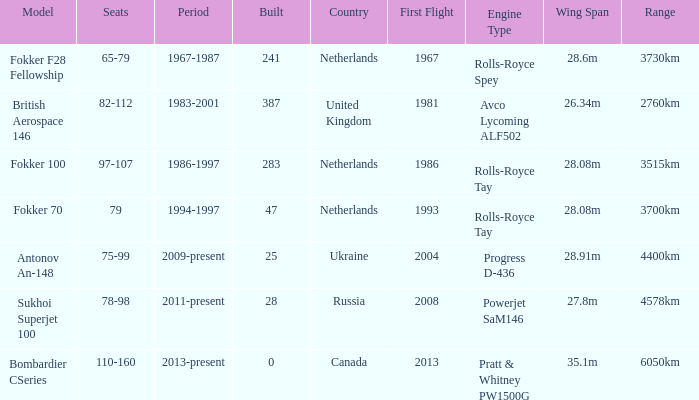Parse the table in full. {'header': ['Model', 'Seats', 'Period', 'Built', 'Country', 'First Flight', 'Engine Type', 'Wing Span', 'Range'], 'rows': [['Fokker F28 Fellowship', '65-79', '1967-1987', '241', 'Netherlands', '1967', 'Rolls-Royce Spey', '28.6m', '3730km'], ['British Aerospace 146', '82-112', '1983-2001', '387', 'United Kingdom', '1981', 'Avco Lycoming ALF502', '26.34m', '2760km'], ['Fokker 100', '97-107', '1986-1997', '283', 'Netherlands', '1986', 'Rolls-Royce Tay', '28.08m', '3515km'], ['Fokker 70', '79', '1994-1997', '47', 'Netherlands', '1993', 'Rolls-Royce Tay', '28.08m', '3700km'], ['Antonov An-148', '75-99', '2009-present', '25', 'Ukraine', '2004', 'Progress D-436', '28.91m', '4400km'], ['Sukhoi Superjet 100', '78-98', '2011-present', '28', 'Russia', '2008', 'Powerjet SaM146', '27.8m', '4578km'], ['Bombardier CSeries', '110-160', '2013-present', '0', 'Canada', '2013', 'Pratt & Whitney PW1500G', '35.1m', '6050km']]} How many cabins were built in the time between 1967-1987? 241.0. 